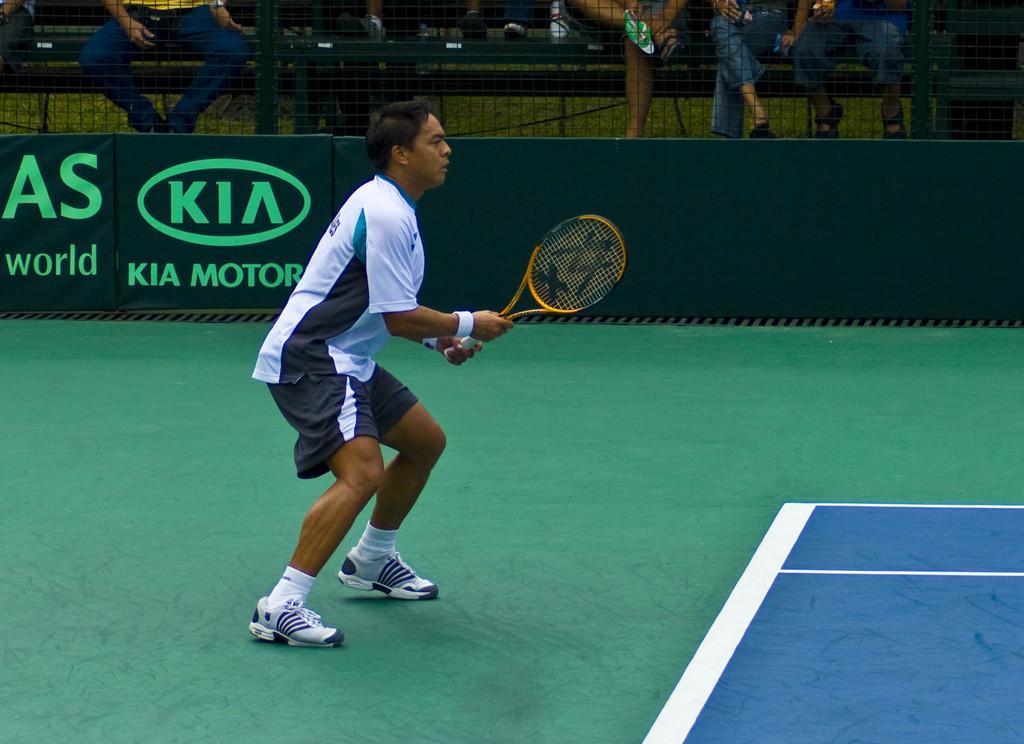Describe this image in one or two sentences. In this picture there is a person wearing white dress is standing and holding a tennis racket in his hands and there is a fence beside him and there are few persons sitting in the background. 